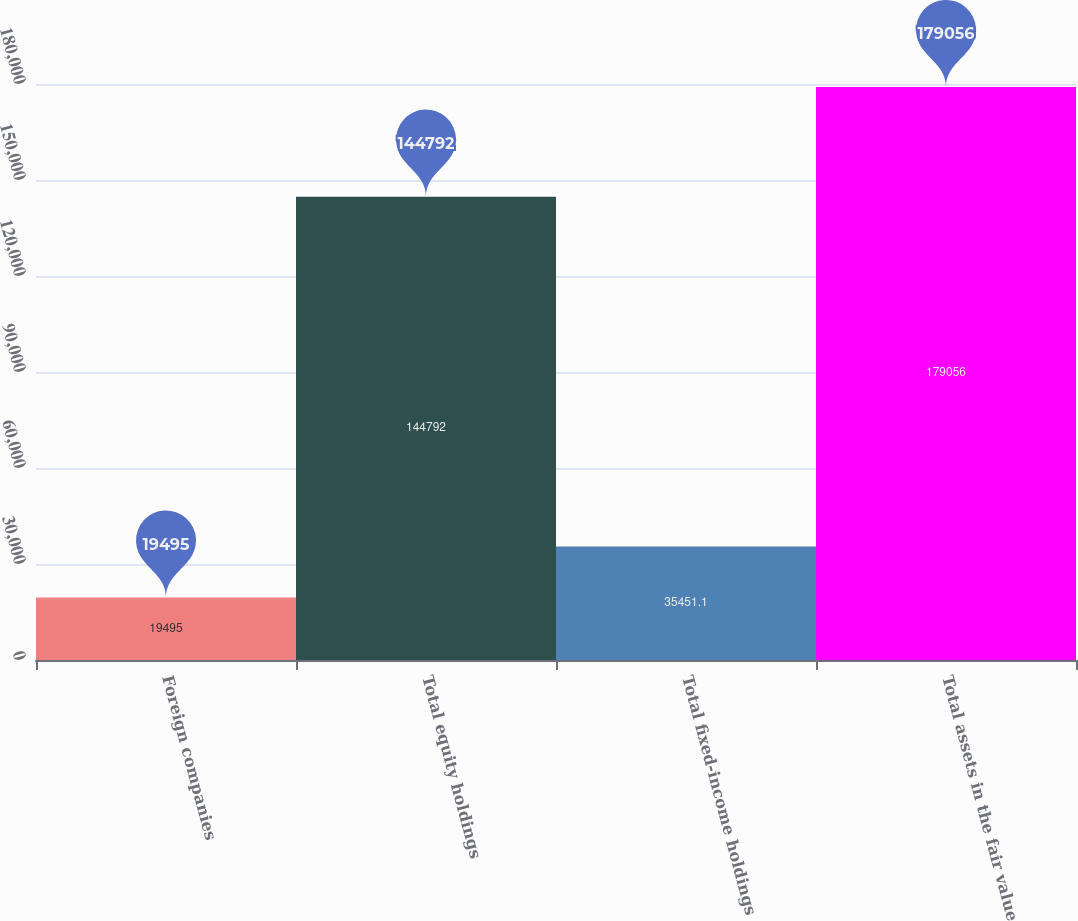<chart> <loc_0><loc_0><loc_500><loc_500><bar_chart><fcel>Foreign companies<fcel>Total equity holdings<fcel>Total fixed-income holdings<fcel>Total assets in the fair value<nl><fcel>19495<fcel>144792<fcel>35451.1<fcel>179056<nl></chart> 